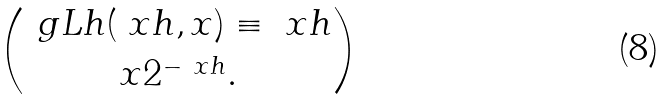<formula> <loc_0><loc_0><loc_500><loc_500>\ g L h ( \ x h , x ) \equiv \ x h \choose x 2 ^ { - \ x h } .</formula> 